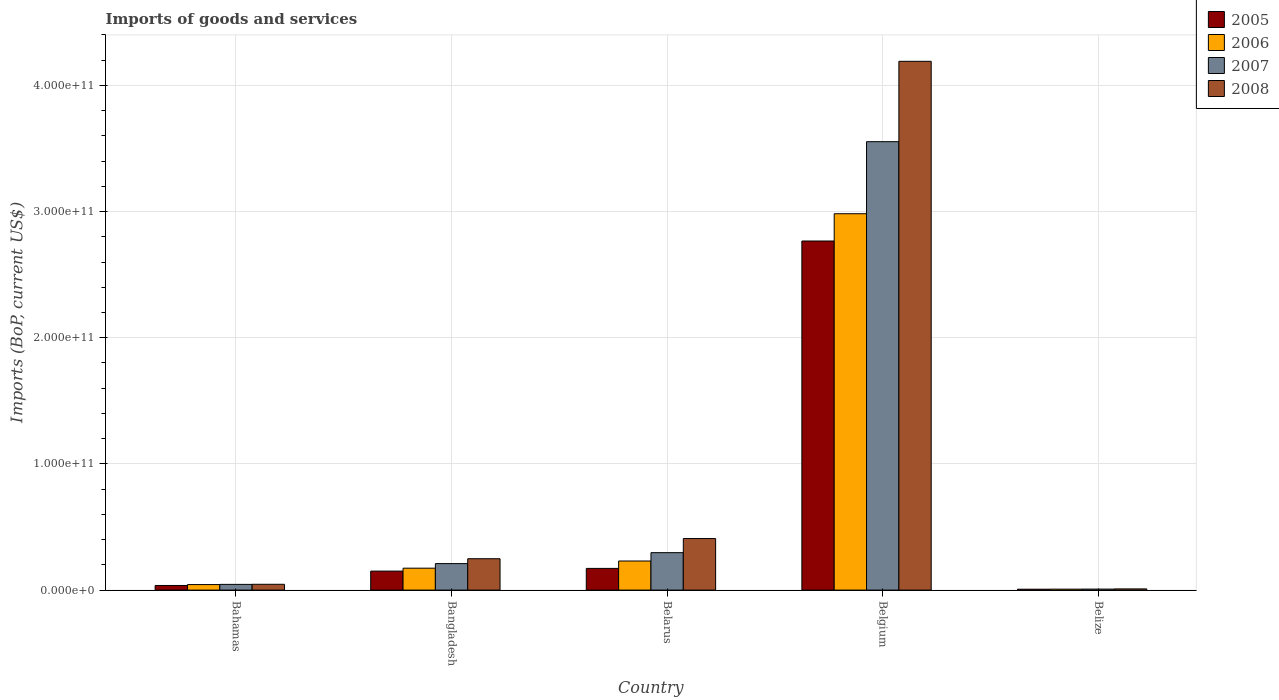How many different coloured bars are there?
Offer a very short reply. 4. How many groups of bars are there?
Your answer should be very brief. 5. Are the number of bars per tick equal to the number of legend labels?
Your response must be concise. Yes. What is the label of the 2nd group of bars from the left?
Give a very brief answer. Bangladesh. In how many cases, is the number of bars for a given country not equal to the number of legend labels?
Keep it short and to the point. 0. What is the amount spent on imports in 2005 in Belize?
Offer a very short reply. 7.03e+08. Across all countries, what is the maximum amount spent on imports in 2006?
Your answer should be very brief. 2.98e+11. Across all countries, what is the minimum amount spent on imports in 2008?
Provide a short and direct response. 9.58e+08. In which country was the amount spent on imports in 2007 minimum?
Give a very brief answer. Belize. What is the total amount spent on imports in 2006 in the graph?
Make the answer very short. 3.44e+11. What is the difference between the amount spent on imports in 2007 in Bahamas and that in Belgium?
Offer a very short reply. -3.51e+11. What is the difference between the amount spent on imports in 2007 in Belize and the amount spent on imports in 2006 in Bahamas?
Offer a very short reply. -3.57e+09. What is the average amount spent on imports in 2008 per country?
Make the answer very short. 9.81e+1. What is the difference between the amount spent on imports of/in 2007 and amount spent on imports of/in 2008 in Bangladesh?
Your response must be concise. -3.86e+09. In how many countries, is the amount spent on imports in 2007 greater than 80000000000 US$?
Your answer should be compact. 1. What is the ratio of the amount spent on imports in 2007 in Bangladesh to that in Belgium?
Ensure brevity in your answer.  0.06. Is the amount spent on imports in 2007 in Belgium less than that in Belize?
Your response must be concise. No. Is the difference between the amount spent on imports in 2007 in Bahamas and Belgium greater than the difference between the amount spent on imports in 2008 in Bahamas and Belgium?
Your answer should be very brief. Yes. What is the difference between the highest and the second highest amount spent on imports in 2005?
Ensure brevity in your answer.  2.62e+11. What is the difference between the highest and the lowest amount spent on imports in 2005?
Your answer should be compact. 2.76e+11. In how many countries, is the amount spent on imports in 2007 greater than the average amount spent on imports in 2007 taken over all countries?
Offer a very short reply. 1. Is the sum of the amount spent on imports in 2006 in Bahamas and Belize greater than the maximum amount spent on imports in 2005 across all countries?
Provide a succinct answer. No. Is it the case that in every country, the sum of the amount spent on imports in 2007 and amount spent on imports in 2008 is greater than the sum of amount spent on imports in 2005 and amount spent on imports in 2006?
Your answer should be compact. No. What does the 2nd bar from the left in Belgium represents?
Provide a succinct answer. 2006. How many bars are there?
Ensure brevity in your answer.  20. Are all the bars in the graph horizontal?
Offer a terse response. No. How many countries are there in the graph?
Offer a terse response. 5. What is the difference between two consecutive major ticks on the Y-axis?
Offer a terse response. 1.00e+11. Are the values on the major ticks of Y-axis written in scientific E-notation?
Offer a terse response. Yes. Does the graph contain any zero values?
Give a very brief answer. No. How are the legend labels stacked?
Ensure brevity in your answer.  Vertical. What is the title of the graph?
Ensure brevity in your answer.  Imports of goods and services. What is the label or title of the Y-axis?
Provide a short and direct response. Imports (BoP, current US$). What is the Imports (BoP, current US$) in 2005 in Bahamas?
Provide a short and direct response. 3.66e+09. What is the Imports (BoP, current US$) in 2006 in Bahamas?
Provide a succinct answer. 4.38e+09. What is the Imports (BoP, current US$) in 2007 in Bahamas?
Give a very brief answer. 4.54e+09. What is the Imports (BoP, current US$) in 2008 in Bahamas?
Provide a succinct answer. 4.60e+09. What is the Imports (BoP, current US$) of 2005 in Bangladesh?
Give a very brief answer. 1.51e+1. What is the Imports (BoP, current US$) in 2006 in Bangladesh?
Provide a short and direct response. 1.74e+1. What is the Imports (BoP, current US$) of 2007 in Bangladesh?
Ensure brevity in your answer.  2.10e+1. What is the Imports (BoP, current US$) of 2008 in Bangladesh?
Your answer should be very brief. 2.49e+1. What is the Imports (BoP, current US$) of 2005 in Belarus?
Offer a terse response. 1.72e+1. What is the Imports (BoP, current US$) in 2006 in Belarus?
Offer a very short reply. 2.31e+1. What is the Imports (BoP, current US$) of 2007 in Belarus?
Your answer should be compact. 2.97e+1. What is the Imports (BoP, current US$) of 2008 in Belarus?
Provide a short and direct response. 4.09e+1. What is the Imports (BoP, current US$) in 2005 in Belgium?
Your answer should be compact. 2.77e+11. What is the Imports (BoP, current US$) of 2006 in Belgium?
Your answer should be very brief. 2.98e+11. What is the Imports (BoP, current US$) of 2007 in Belgium?
Offer a terse response. 3.55e+11. What is the Imports (BoP, current US$) of 2008 in Belgium?
Provide a short and direct response. 4.19e+11. What is the Imports (BoP, current US$) of 2005 in Belize?
Make the answer very short. 7.03e+08. What is the Imports (BoP, current US$) of 2006 in Belize?
Your answer should be very brief. 7.50e+08. What is the Imports (BoP, current US$) of 2007 in Belize?
Make the answer very short. 8.03e+08. What is the Imports (BoP, current US$) in 2008 in Belize?
Provide a short and direct response. 9.58e+08. Across all countries, what is the maximum Imports (BoP, current US$) of 2005?
Keep it short and to the point. 2.77e+11. Across all countries, what is the maximum Imports (BoP, current US$) in 2006?
Offer a terse response. 2.98e+11. Across all countries, what is the maximum Imports (BoP, current US$) of 2007?
Your answer should be compact. 3.55e+11. Across all countries, what is the maximum Imports (BoP, current US$) in 2008?
Your answer should be compact. 4.19e+11. Across all countries, what is the minimum Imports (BoP, current US$) in 2005?
Your response must be concise. 7.03e+08. Across all countries, what is the minimum Imports (BoP, current US$) of 2006?
Provide a short and direct response. 7.50e+08. Across all countries, what is the minimum Imports (BoP, current US$) of 2007?
Your answer should be compact. 8.03e+08. Across all countries, what is the minimum Imports (BoP, current US$) of 2008?
Your answer should be compact. 9.58e+08. What is the total Imports (BoP, current US$) of 2005 in the graph?
Your answer should be very brief. 3.13e+11. What is the total Imports (BoP, current US$) of 2006 in the graph?
Provide a succinct answer. 3.44e+11. What is the total Imports (BoP, current US$) of 2007 in the graph?
Keep it short and to the point. 4.11e+11. What is the total Imports (BoP, current US$) in 2008 in the graph?
Provide a short and direct response. 4.90e+11. What is the difference between the Imports (BoP, current US$) in 2005 in Bahamas and that in Bangladesh?
Your response must be concise. -1.14e+1. What is the difference between the Imports (BoP, current US$) of 2006 in Bahamas and that in Bangladesh?
Keep it short and to the point. -1.30e+1. What is the difference between the Imports (BoP, current US$) of 2007 in Bahamas and that in Bangladesh?
Make the answer very short. -1.65e+1. What is the difference between the Imports (BoP, current US$) of 2008 in Bahamas and that in Bangladesh?
Ensure brevity in your answer.  -2.03e+1. What is the difference between the Imports (BoP, current US$) of 2005 in Bahamas and that in Belarus?
Keep it short and to the point. -1.35e+1. What is the difference between the Imports (BoP, current US$) of 2006 in Bahamas and that in Belarus?
Make the answer very short. -1.87e+1. What is the difference between the Imports (BoP, current US$) in 2007 in Bahamas and that in Belarus?
Make the answer very short. -2.51e+1. What is the difference between the Imports (BoP, current US$) in 2008 in Bahamas and that in Belarus?
Ensure brevity in your answer.  -3.63e+1. What is the difference between the Imports (BoP, current US$) in 2005 in Bahamas and that in Belgium?
Offer a very short reply. -2.73e+11. What is the difference between the Imports (BoP, current US$) of 2006 in Bahamas and that in Belgium?
Your answer should be compact. -2.94e+11. What is the difference between the Imports (BoP, current US$) of 2007 in Bahamas and that in Belgium?
Provide a short and direct response. -3.51e+11. What is the difference between the Imports (BoP, current US$) of 2008 in Bahamas and that in Belgium?
Your response must be concise. -4.14e+11. What is the difference between the Imports (BoP, current US$) of 2005 in Bahamas and that in Belize?
Offer a very short reply. 2.96e+09. What is the difference between the Imports (BoP, current US$) of 2006 in Bahamas and that in Belize?
Keep it short and to the point. 3.63e+09. What is the difference between the Imports (BoP, current US$) in 2007 in Bahamas and that in Belize?
Your response must be concise. 3.73e+09. What is the difference between the Imports (BoP, current US$) in 2008 in Bahamas and that in Belize?
Give a very brief answer. 3.64e+09. What is the difference between the Imports (BoP, current US$) in 2005 in Bangladesh and that in Belarus?
Make the answer very short. -2.14e+09. What is the difference between the Imports (BoP, current US$) in 2006 in Bangladesh and that in Belarus?
Provide a short and direct response. -5.69e+09. What is the difference between the Imports (BoP, current US$) of 2007 in Bangladesh and that in Belarus?
Give a very brief answer. -8.66e+09. What is the difference between the Imports (BoP, current US$) of 2008 in Bangladesh and that in Belarus?
Your response must be concise. -1.60e+1. What is the difference between the Imports (BoP, current US$) of 2005 in Bangladesh and that in Belgium?
Your response must be concise. -2.62e+11. What is the difference between the Imports (BoP, current US$) in 2006 in Bangladesh and that in Belgium?
Give a very brief answer. -2.81e+11. What is the difference between the Imports (BoP, current US$) of 2007 in Bangladesh and that in Belgium?
Ensure brevity in your answer.  -3.34e+11. What is the difference between the Imports (BoP, current US$) of 2008 in Bangladesh and that in Belgium?
Make the answer very short. -3.94e+11. What is the difference between the Imports (BoP, current US$) in 2005 in Bangladesh and that in Belize?
Ensure brevity in your answer.  1.44e+1. What is the difference between the Imports (BoP, current US$) in 2006 in Bangladesh and that in Belize?
Offer a terse response. 1.66e+1. What is the difference between the Imports (BoP, current US$) of 2007 in Bangladesh and that in Belize?
Your response must be concise. 2.02e+1. What is the difference between the Imports (BoP, current US$) of 2008 in Bangladesh and that in Belize?
Make the answer very short. 2.39e+1. What is the difference between the Imports (BoP, current US$) of 2005 in Belarus and that in Belgium?
Give a very brief answer. -2.59e+11. What is the difference between the Imports (BoP, current US$) of 2006 in Belarus and that in Belgium?
Your response must be concise. -2.75e+11. What is the difference between the Imports (BoP, current US$) in 2007 in Belarus and that in Belgium?
Your answer should be very brief. -3.26e+11. What is the difference between the Imports (BoP, current US$) in 2008 in Belarus and that in Belgium?
Keep it short and to the point. -3.78e+11. What is the difference between the Imports (BoP, current US$) in 2005 in Belarus and that in Belize?
Your answer should be compact. 1.65e+1. What is the difference between the Imports (BoP, current US$) in 2006 in Belarus and that in Belize?
Your answer should be very brief. 2.23e+1. What is the difference between the Imports (BoP, current US$) of 2007 in Belarus and that in Belize?
Your answer should be very brief. 2.89e+1. What is the difference between the Imports (BoP, current US$) of 2008 in Belarus and that in Belize?
Offer a terse response. 3.99e+1. What is the difference between the Imports (BoP, current US$) of 2005 in Belgium and that in Belize?
Keep it short and to the point. 2.76e+11. What is the difference between the Imports (BoP, current US$) in 2006 in Belgium and that in Belize?
Your answer should be very brief. 2.98e+11. What is the difference between the Imports (BoP, current US$) of 2007 in Belgium and that in Belize?
Provide a short and direct response. 3.55e+11. What is the difference between the Imports (BoP, current US$) in 2008 in Belgium and that in Belize?
Ensure brevity in your answer.  4.18e+11. What is the difference between the Imports (BoP, current US$) in 2005 in Bahamas and the Imports (BoP, current US$) in 2006 in Bangladesh?
Your response must be concise. -1.37e+1. What is the difference between the Imports (BoP, current US$) in 2005 in Bahamas and the Imports (BoP, current US$) in 2007 in Bangladesh?
Your response must be concise. -1.73e+1. What is the difference between the Imports (BoP, current US$) of 2005 in Bahamas and the Imports (BoP, current US$) of 2008 in Bangladesh?
Give a very brief answer. -2.12e+1. What is the difference between the Imports (BoP, current US$) in 2006 in Bahamas and the Imports (BoP, current US$) in 2007 in Bangladesh?
Offer a very short reply. -1.66e+1. What is the difference between the Imports (BoP, current US$) of 2006 in Bahamas and the Imports (BoP, current US$) of 2008 in Bangladesh?
Make the answer very short. -2.05e+1. What is the difference between the Imports (BoP, current US$) of 2007 in Bahamas and the Imports (BoP, current US$) of 2008 in Bangladesh?
Keep it short and to the point. -2.03e+1. What is the difference between the Imports (BoP, current US$) in 2005 in Bahamas and the Imports (BoP, current US$) in 2006 in Belarus?
Keep it short and to the point. -1.94e+1. What is the difference between the Imports (BoP, current US$) of 2005 in Bahamas and the Imports (BoP, current US$) of 2007 in Belarus?
Provide a short and direct response. -2.60e+1. What is the difference between the Imports (BoP, current US$) of 2005 in Bahamas and the Imports (BoP, current US$) of 2008 in Belarus?
Your answer should be very brief. -3.72e+1. What is the difference between the Imports (BoP, current US$) in 2006 in Bahamas and the Imports (BoP, current US$) in 2007 in Belarus?
Provide a succinct answer. -2.53e+1. What is the difference between the Imports (BoP, current US$) in 2006 in Bahamas and the Imports (BoP, current US$) in 2008 in Belarus?
Provide a succinct answer. -3.65e+1. What is the difference between the Imports (BoP, current US$) of 2007 in Bahamas and the Imports (BoP, current US$) of 2008 in Belarus?
Your answer should be compact. -3.63e+1. What is the difference between the Imports (BoP, current US$) of 2005 in Bahamas and the Imports (BoP, current US$) of 2006 in Belgium?
Your answer should be compact. -2.95e+11. What is the difference between the Imports (BoP, current US$) in 2005 in Bahamas and the Imports (BoP, current US$) in 2007 in Belgium?
Your response must be concise. -3.52e+11. What is the difference between the Imports (BoP, current US$) of 2005 in Bahamas and the Imports (BoP, current US$) of 2008 in Belgium?
Your response must be concise. -4.15e+11. What is the difference between the Imports (BoP, current US$) of 2006 in Bahamas and the Imports (BoP, current US$) of 2007 in Belgium?
Ensure brevity in your answer.  -3.51e+11. What is the difference between the Imports (BoP, current US$) in 2006 in Bahamas and the Imports (BoP, current US$) in 2008 in Belgium?
Keep it short and to the point. -4.15e+11. What is the difference between the Imports (BoP, current US$) in 2007 in Bahamas and the Imports (BoP, current US$) in 2008 in Belgium?
Offer a terse response. -4.15e+11. What is the difference between the Imports (BoP, current US$) of 2005 in Bahamas and the Imports (BoP, current US$) of 2006 in Belize?
Your answer should be compact. 2.91e+09. What is the difference between the Imports (BoP, current US$) of 2005 in Bahamas and the Imports (BoP, current US$) of 2007 in Belize?
Give a very brief answer. 2.86e+09. What is the difference between the Imports (BoP, current US$) in 2005 in Bahamas and the Imports (BoP, current US$) in 2008 in Belize?
Offer a very short reply. 2.71e+09. What is the difference between the Imports (BoP, current US$) in 2006 in Bahamas and the Imports (BoP, current US$) in 2007 in Belize?
Keep it short and to the point. 3.57e+09. What is the difference between the Imports (BoP, current US$) of 2006 in Bahamas and the Imports (BoP, current US$) of 2008 in Belize?
Your answer should be very brief. 3.42e+09. What is the difference between the Imports (BoP, current US$) in 2007 in Bahamas and the Imports (BoP, current US$) in 2008 in Belize?
Your response must be concise. 3.58e+09. What is the difference between the Imports (BoP, current US$) in 2005 in Bangladesh and the Imports (BoP, current US$) in 2006 in Belarus?
Your answer should be compact. -8.01e+09. What is the difference between the Imports (BoP, current US$) of 2005 in Bangladesh and the Imports (BoP, current US$) of 2007 in Belarus?
Give a very brief answer. -1.46e+1. What is the difference between the Imports (BoP, current US$) of 2005 in Bangladesh and the Imports (BoP, current US$) of 2008 in Belarus?
Your answer should be compact. -2.58e+1. What is the difference between the Imports (BoP, current US$) of 2006 in Bangladesh and the Imports (BoP, current US$) of 2007 in Belarus?
Give a very brief answer. -1.23e+1. What is the difference between the Imports (BoP, current US$) in 2006 in Bangladesh and the Imports (BoP, current US$) in 2008 in Belarus?
Your answer should be compact. -2.35e+1. What is the difference between the Imports (BoP, current US$) of 2007 in Bangladesh and the Imports (BoP, current US$) of 2008 in Belarus?
Ensure brevity in your answer.  -1.99e+1. What is the difference between the Imports (BoP, current US$) of 2005 in Bangladesh and the Imports (BoP, current US$) of 2006 in Belgium?
Your response must be concise. -2.83e+11. What is the difference between the Imports (BoP, current US$) in 2005 in Bangladesh and the Imports (BoP, current US$) in 2007 in Belgium?
Give a very brief answer. -3.40e+11. What is the difference between the Imports (BoP, current US$) in 2005 in Bangladesh and the Imports (BoP, current US$) in 2008 in Belgium?
Offer a terse response. -4.04e+11. What is the difference between the Imports (BoP, current US$) in 2006 in Bangladesh and the Imports (BoP, current US$) in 2007 in Belgium?
Offer a terse response. -3.38e+11. What is the difference between the Imports (BoP, current US$) of 2006 in Bangladesh and the Imports (BoP, current US$) of 2008 in Belgium?
Make the answer very short. -4.02e+11. What is the difference between the Imports (BoP, current US$) in 2007 in Bangladesh and the Imports (BoP, current US$) in 2008 in Belgium?
Offer a very short reply. -3.98e+11. What is the difference between the Imports (BoP, current US$) in 2005 in Bangladesh and the Imports (BoP, current US$) in 2006 in Belize?
Provide a short and direct response. 1.43e+1. What is the difference between the Imports (BoP, current US$) in 2005 in Bangladesh and the Imports (BoP, current US$) in 2007 in Belize?
Ensure brevity in your answer.  1.43e+1. What is the difference between the Imports (BoP, current US$) in 2005 in Bangladesh and the Imports (BoP, current US$) in 2008 in Belize?
Ensure brevity in your answer.  1.41e+1. What is the difference between the Imports (BoP, current US$) in 2006 in Bangladesh and the Imports (BoP, current US$) in 2007 in Belize?
Offer a terse response. 1.66e+1. What is the difference between the Imports (BoP, current US$) of 2006 in Bangladesh and the Imports (BoP, current US$) of 2008 in Belize?
Offer a very short reply. 1.64e+1. What is the difference between the Imports (BoP, current US$) of 2007 in Bangladesh and the Imports (BoP, current US$) of 2008 in Belize?
Provide a short and direct response. 2.00e+1. What is the difference between the Imports (BoP, current US$) in 2005 in Belarus and the Imports (BoP, current US$) in 2006 in Belgium?
Ensure brevity in your answer.  -2.81e+11. What is the difference between the Imports (BoP, current US$) in 2005 in Belarus and the Imports (BoP, current US$) in 2007 in Belgium?
Your answer should be compact. -3.38e+11. What is the difference between the Imports (BoP, current US$) in 2005 in Belarus and the Imports (BoP, current US$) in 2008 in Belgium?
Offer a very short reply. -4.02e+11. What is the difference between the Imports (BoP, current US$) of 2006 in Belarus and the Imports (BoP, current US$) of 2007 in Belgium?
Your answer should be very brief. -3.32e+11. What is the difference between the Imports (BoP, current US$) in 2006 in Belarus and the Imports (BoP, current US$) in 2008 in Belgium?
Ensure brevity in your answer.  -3.96e+11. What is the difference between the Imports (BoP, current US$) in 2007 in Belarus and the Imports (BoP, current US$) in 2008 in Belgium?
Offer a terse response. -3.89e+11. What is the difference between the Imports (BoP, current US$) in 2005 in Belarus and the Imports (BoP, current US$) in 2006 in Belize?
Your response must be concise. 1.64e+1. What is the difference between the Imports (BoP, current US$) in 2005 in Belarus and the Imports (BoP, current US$) in 2007 in Belize?
Make the answer very short. 1.64e+1. What is the difference between the Imports (BoP, current US$) of 2005 in Belarus and the Imports (BoP, current US$) of 2008 in Belize?
Your response must be concise. 1.62e+1. What is the difference between the Imports (BoP, current US$) in 2006 in Belarus and the Imports (BoP, current US$) in 2007 in Belize?
Your answer should be compact. 2.23e+1. What is the difference between the Imports (BoP, current US$) of 2006 in Belarus and the Imports (BoP, current US$) of 2008 in Belize?
Your answer should be very brief. 2.21e+1. What is the difference between the Imports (BoP, current US$) in 2007 in Belarus and the Imports (BoP, current US$) in 2008 in Belize?
Provide a short and direct response. 2.87e+1. What is the difference between the Imports (BoP, current US$) in 2005 in Belgium and the Imports (BoP, current US$) in 2006 in Belize?
Your answer should be very brief. 2.76e+11. What is the difference between the Imports (BoP, current US$) of 2005 in Belgium and the Imports (BoP, current US$) of 2007 in Belize?
Ensure brevity in your answer.  2.76e+11. What is the difference between the Imports (BoP, current US$) of 2005 in Belgium and the Imports (BoP, current US$) of 2008 in Belize?
Provide a succinct answer. 2.76e+11. What is the difference between the Imports (BoP, current US$) of 2006 in Belgium and the Imports (BoP, current US$) of 2007 in Belize?
Ensure brevity in your answer.  2.97e+11. What is the difference between the Imports (BoP, current US$) of 2006 in Belgium and the Imports (BoP, current US$) of 2008 in Belize?
Your response must be concise. 2.97e+11. What is the difference between the Imports (BoP, current US$) in 2007 in Belgium and the Imports (BoP, current US$) in 2008 in Belize?
Offer a very short reply. 3.54e+11. What is the average Imports (BoP, current US$) of 2005 per country?
Your answer should be compact. 6.27e+1. What is the average Imports (BoP, current US$) of 2006 per country?
Give a very brief answer. 6.88e+1. What is the average Imports (BoP, current US$) in 2007 per country?
Keep it short and to the point. 8.23e+1. What is the average Imports (BoP, current US$) in 2008 per country?
Provide a succinct answer. 9.81e+1. What is the difference between the Imports (BoP, current US$) of 2005 and Imports (BoP, current US$) of 2006 in Bahamas?
Give a very brief answer. -7.14e+08. What is the difference between the Imports (BoP, current US$) in 2005 and Imports (BoP, current US$) in 2007 in Bahamas?
Give a very brief answer. -8.73e+08. What is the difference between the Imports (BoP, current US$) in 2005 and Imports (BoP, current US$) in 2008 in Bahamas?
Ensure brevity in your answer.  -9.38e+08. What is the difference between the Imports (BoP, current US$) in 2006 and Imports (BoP, current US$) in 2007 in Bahamas?
Provide a succinct answer. -1.59e+08. What is the difference between the Imports (BoP, current US$) of 2006 and Imports (BoP, current US$) of 2008 in Bahamas?
Ensure brevity in your answer.  -2.25e+08. What is the difference between the Imports (BoP, current US$) in 2007 and Imports (BoP, current US$) in 2008 in Bahamas?
Offer a very short reply. -6.54e+07. What is the difference between the Imports (BoP, current US$) of 2005 and Imports (BoP, current US$) of 2006 in Bangladesh?
Provide a short and direct response. -2.31e+09. What is the difference between the Imports (BoP, current US$) in 2005 and Imports (BoP, current US$) in 2007 in Bangladesh?
Give a very brief answer. -5.95e+09. What is the difference between the Imports (BoP, current US$) of 2005 and Imports (BoP, current US$) of 2008 in Bangladesh?
Provide a short and direct response. -9.81e+09. What is the difference between the Imports (BoP, current US$) of 2006 and Imports (BoP, current US$) of 2007 in Bangladesh?
Offer a very short reply. -3.64e+09. What is the difference between the Imports (BoP, current US$) in 2006 and Imports (BoP, current US$) in 2008 in Bangladesh?
Offer a very short reply. -7.50e+09. What is the difference between the Imports (BoP, current US$) of 2007 and Imports (BoP, current US$) of 2008 in Bangladesh?
Keep it short and to the point. -3.86e+09. What is the difference between the Imports (BoP, current US$) of 2005 and Imports (BoP, current US$) of 2006 in Belarus?
Provide a succinct answer. -5.87e+09. What is the difference between the Imports (BoP, current US$) of 2005 and Imports (BoP, current US$) of 2007 in Belarus?
Provide a short and direct response. -1.25e+1. What is the difference between the Imports (BoP, current US$) in 2005 and Imports (BoP, current US$) in 2008 in Belarus?
Your answer should be compact. -2.37e+1. What is the difference between the Imports (BoP, current US$) of 2006 and Imports (BoP, current US$) of 2007 in Belarus?
Keep it short and to the point. -6.61e+09. What is the difference between the Imports (BoP, current US$) of 2006 and Imports (BoP, current US$) of 2008 in Belarus?
Offer a very short reply. -1.78e+1. What is the difference between the Imports (BoP, current US$) in 2007 and Imports (BoP, current US$) in 2008 in Belarus?
Make the answer very short. -1.12e+1. What is the difference between the Imports (BoP, current US$) in 2005 and Imports (BoP, current US$) in 2006 in Belgium?
Your response must be concise. -2.16e+1. What is the difference between the Imports (BoP, current US$) in 2005 and Imports (BoP, current US$) in 2007 in Belgium?
Ensure brevity in your answer.  -7.87e+1. What is the difference between the Imports (BoP, current US$) of 2005 and Imports (BoP, current US$) of 2008 in Belgium?
Provide a succinct answer. -1.42e+11. What is the difference between the Imports (BoP, current US$) in 2006 and Imports (BoP, current US$) in 2007 in Belgium?
Keep it short and to the point. -5.71e+1. What is the difference between the Imports (BoP, current US$) in 2006 and Imports (BoP, current US$) in 2008 in Belgium?
Your response must be concise. -1.21e+11. What is the difference between the Imports (BoP, current US$) of 2007 and Imports (BoP, current US$) of 2008 in Belgium?
Provide a succinct answer. -6.37e+1. What is the difference between the Imports (BoP, current US$) of 2005 and Imports (BoP, current US$) of 2006 in Belize?
Your answer should be compact. -4.70e+07. What is the difference between the Imports (BoP, current US$) of 2005 and Imports (BoP, current US$) of 2007 in Belize?
Your answer should be compact. -9.99e+07. What is the difference between the Imports (BoP, current US$) in 2005 and Imports (BoP, current US$) in 2008 in Belize?
Provide a succinct answer. -2.55e+08. What is the difference between the Imports (BoP, current US$) in 2006 and Imports (BoP, current US$) in 2007 in Belize?
Provide a short and direct response. -5.28e+07. What is the difference between the Imports (BoP, current US$) of 2006 and Imports (BoP, current US$) of 2008 in Belize?
Keep it short and to the point. -2.08e+08. What is the difference between the Imports (BoP, current US$) of 2007 and Imports (BoP, current US$) of 2008 in Belize?
Make the answer very short. -1.55e+08. What is the ratio of the Imports (BoP, current US$) in 2005 in Bahamas to that in Bangladesh?
Make the answer very short. 0.24. What is the ratio of the Imports (BoP, current US$) of 2006 in Bahamas to that in Bangladesh?
Ensure brevity in your answer.  0.25. What is the ratio of the Imports (BoP, current US$) in 2007 in Bahamas to that in Bangladesh?
Your response must be concise. 0.22. What is the ratio of the Imports (BoP, current US$) in 2008 in Bahamas to that in Bangladesh?
Your answer should be compact. 0.19. What is the ratio of the Imports (BoP, current US$) in 2005 in Bahamas to that in Belarus?
Make the answer very short. 0.21. What is the ratio of the Imports (BoP, current US$) in 2006 in Bahamas to that in Belarus?
Make the answer very short. 0.19. What is the ratio of the Imports (BoP, current US$) in 2007 in Bahamas to that in Belarus?
Offer a very short reply. 0.15. What is the ratio of the Imports (BoP, current US$) in 2008 in Bahamas to that in Belarus?
Offer a very short reply. 0.11. What is the ratio of the Imports (BoP, current US$) in 2005 in Bahamas to that in Belgium?
Provide a succinct answer. 0.01. What is the ratio of the Imports (BoP, current US$) in 2006 in Bahamas to that in Belgium?
Ensure brevity in your answer.  0.01. What is the ratio of the Imports (BoP, current US$) of 2007 in Bahamas to that in Belgium?
Offer a terse response. 0.01. What is the ratio of the Imports (BoP, current US$) in 2008 in Bahamas to that in Belgium?
Provide a short and direct response. 0.01. What is the ratio of the Imports (BoP, current US$) of 2005 in Bahamas to that in Belize?
Offer a terse response. 5.21. What is the ratio of the Imports (BoP, current US$) of 2006 in Bahamas to that in Belize?
Ensure brevity in your answer.  5.84. What is the ratio of the Imports (BoP, current US$) of 2007 in Bahamas to that in Belize?
Give a very brief answer. 5.65. What is the ratio of the Imports (BoP, current US$) of 2008 in Bahamas to that in Belize?
Offer a very short reply. 4.8. What is the ratio of the Imports (BoP, current US$) of 2005 in Bangladesh to that in Belarus?
Ensure brevity in your answer.  0.88. What is the ratio of the Imports (BoP, current US$) of 2006 in Bangladesh to that in Belarus?
Provide a short and direct response. 0.75. What is the ratio of the Imports (BoP, current US$) in 2007 in Bangladesh to that in Belarus?
Your answer should be compact. 0.71. What is the ratio of the Imports (BoP, current US$) of 2008 in Bangladesh to that in Belarus?
Your answer should be compact. 0.61. What is the ratio of the Imports (BoP, current US$) of 2005 in Bangladesh to that in Belgium?
Your answer should be very brief. 0.05. What is the ratio of the Imports (BoP, current US$) in 2006 in Bangladesh to that in Belgium?
Offer a terse response. 0.06. What is the ratio of the Imports (BoP, current US$) in 2007 in Bangladesh to that in Belgium?
Keep it short and to the point. 0.06. What is the ratio of the Imports (BoP, current US$) of 2008 in Bangladesh to that in Belgium?
Make the answer very short. 0.06. What is the ratio of the Imports (BoP, current US$) in 2005 in Bangladesh to that in Belize?
Keep it short and to the point. 21.42. What is the ratio of the Imports (BoP, current US$) of 2006 in Bangladesh to that in Belize?
Provide a short and direct response. 23.16. What is the ratio of the Imports (BoP, current US$) of 2007 in Bangladesh to that in Belize?
Your answer should be compact. 26.16. What is the ratio of the Imports (BoP, current US$) of 2008 in Bangladesh to that in Belize?
Ensure brevity in your answer.  25.96. What is the ratio of the Imports (BoP, current US$) in 2005 in Belarus to that in Belgium?
Give a very brief answer. 0.06. What is the ratio of the Imports (BoP, current US$) in 2006 in Belarus to that in Belgium?
Give a very brief answer. 0.08. What is the ratio of the Imports (BoP, current US$) in 2007 in Belarus to that in Belgium?
Your response must be concise. 0.08. What is the ratio of the Imports (BoP, current US$) in 2008 in Belarus to that in Belgium?
Offer a terse response. 0.1. What is the ratio of the Imports (BoP, current US$) in 2005 in Belarus to that in Belize?
Provide a succinct answer. 24.46. What is the ratio of the Imports (BoP, current US$) in 2006 in Belarus to that in Belize?
Offer a terse response. 30.75. What is the ratio of the Imports (BoP, current US$) in 2007 in Belarus to that in Belize?
Your response must be concise. 36.95. What is the ratio of the Imports (BoP, current US$) in 2008 in Belarus to that in Belize?
Provide a short and direct response. 42.67. What is the ratio of the Imports (BoP, current US$) of 2005 in Belgium to that in Belize?
Your response must be concise. 393.56. What is the ratio of the Imports (BoP, current US$) in 2006 in Belgium to that in Belize?
Your answer should be very brief. 397.69. What is the ratio of the Imports (BoP, current US$) in 2007 in Belgium to that in Belize?
Provide a succinct answer. 442.64. What is the ratio of the Imports (BoP, current US$) of 2008 in Belgium to that in Belize?
Provide a succinct answer. 437.54. What is the difference between the highest and the second highest Imports (BoP, current US$) in 2005?
Provide a short and direct response. 2.59e+11. What is the difference between the highest and the second highest Imports (BoP, current US$) in 2006?
Your answer should be very brief. 2.75e+11. What is the difference between the highest and the second highest Imports (BoP, current US$) of 2007?
Keep it short and to the point. 3.26e+11. What is the difference between the highest and the second highest Imports (BoP, current US$) in 2008?
Your response must be concise. 3.78e+11. What is the difference between the highest and the lowest Imports (BoP, current US$) in 2005?
Provide a succinct answer. 2.76e+11. What is the difference between the highest and the lowest Imports (BoP, current US$) of 2006?
Give a very brief answer. 2.98e+11. What is the difference between the highest and the lowest Imports (BoP, current US$) in 2007?
Offer a terse response. 3.55e+11. What is the difference between the highest and the lowest Imports (BoP, current US$) of 2008?
Offer a very short reply. 4.18e+11. 